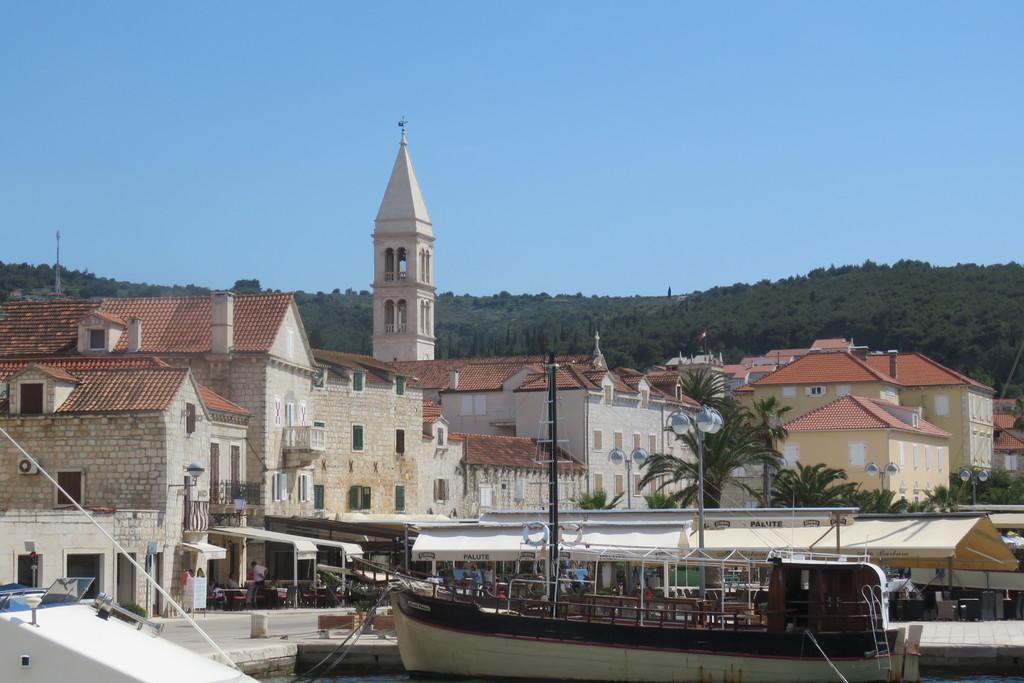Could you give a brief overview of what you see in this image? In this image there is a boat in the center. In the background there are buildings, trees, poles, tents and there are mountains. On the left side in front of the building there is a person standing. 